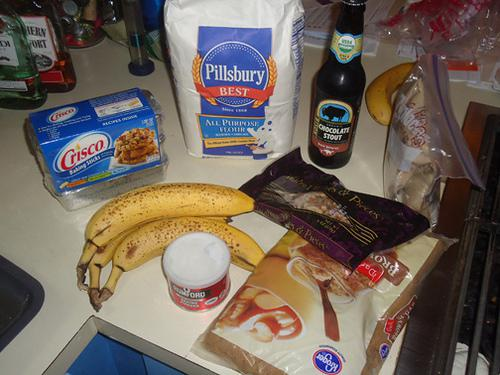Question: how many bananas are in the picture?
Choices:
A. Two.
B. Three.
C. Six.
D. Four.
Answer with the letter. Answer: D Question: what is this a picture of?
Choices:
A. Food.
B. Plates.
C. Flowers.
D. Drinks.
Answer with the letter. Answer: A Question: what is in the white bag?
Choices:
A. Sugar.
B. Flour.
C. Cornmeal.
D. Splenda.
Answer with the letter. Answer: B Question: what flavor is the beer?
Choices:
A. Malt.
B. Vanilla.
C. Strawberry.
D. Chocolate.
Answer with the letter. Answer: D Question: who made the flour?
Choices:
A. Nesquick.
B. Pillsbury.
C. People.
D. Chef.
Answer with the letter. Answer: B Question: what is in the bag in the foreground?
Choices:
A. Flour.
B. Marshmallows.
C. Brown sugar.
D. Beans.
Answer with the letter. Answer: C 